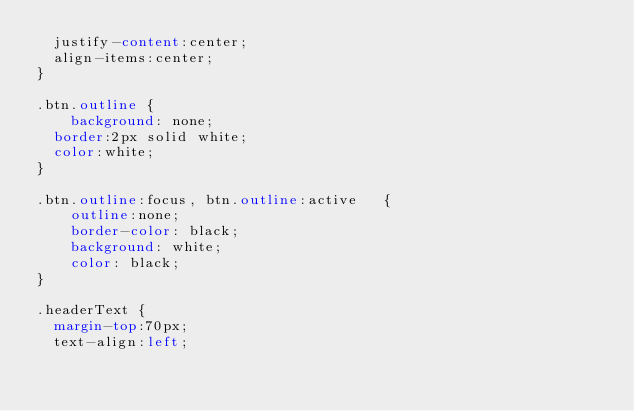Convert code to text. <code><loc_0><loc_0><loc_500><loc_500><_CSS_>  justify-content:center;
  align-items:center;
}

.btn.outline {
    background: none;
  border:2px solid white;
  color:white;
}

.btn.outline:focus, btn.outline:active   {
    outline:none;
    border-color: black;
    background: white;
    color: black;
}

.headerText {
  margin-top:70px;
  text-align:left;</code> 